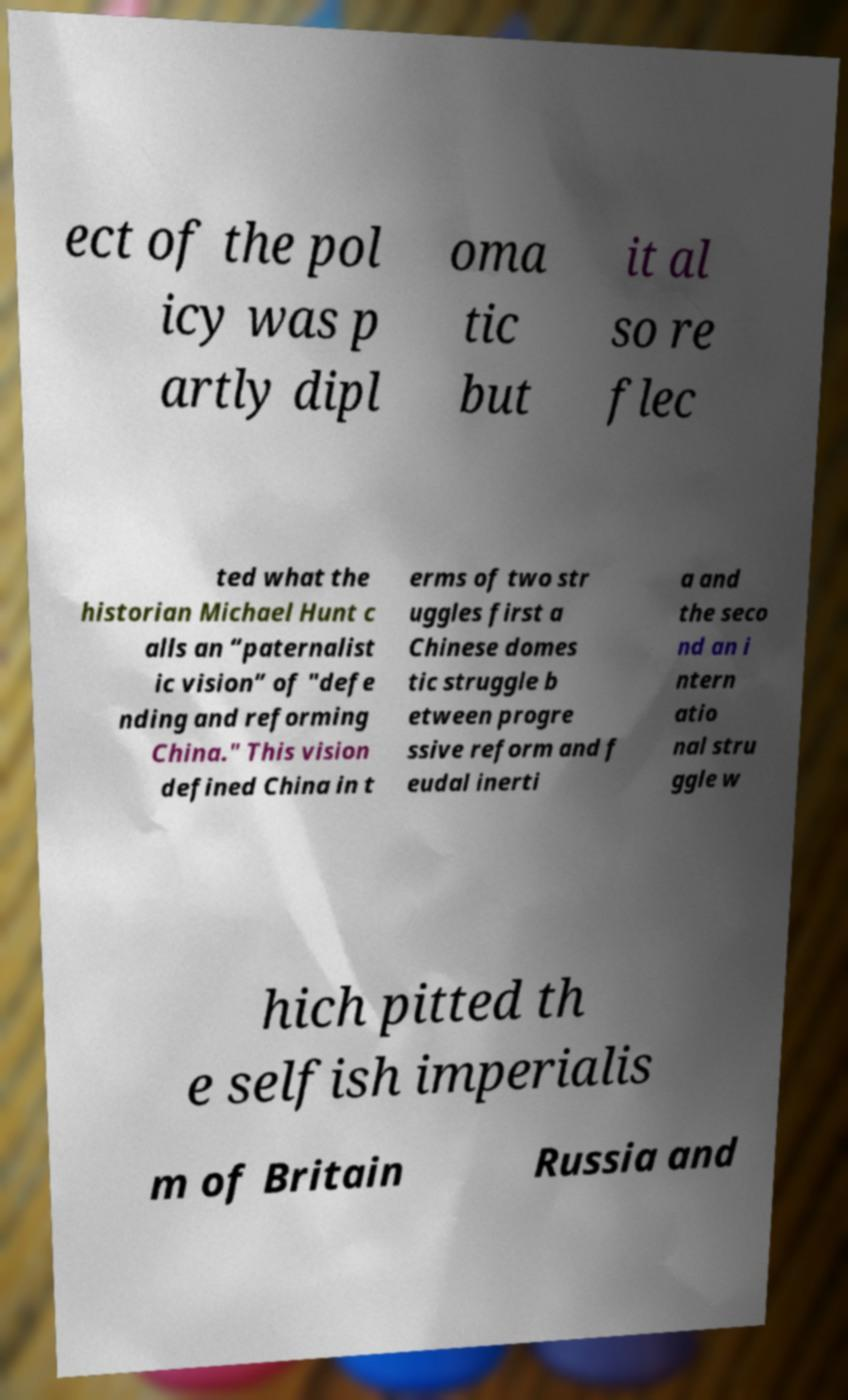Can you accurately transcribe the text from the provided image for me? ect of the pol icy was p artly dipl oma tic but it al so re flec ted what the historian Michael Hunt c alls an “paternalist ic vision” of "defe nding and reforming China." This vision defined China in t erms of two str uggles first a Chinese domes tic struggle b etween progre ssive reform and f eudal inerti a and the seco nd an i ntern atio nal stru ggle w hich pitted th e selfish imperialis m of Britain Russia and 